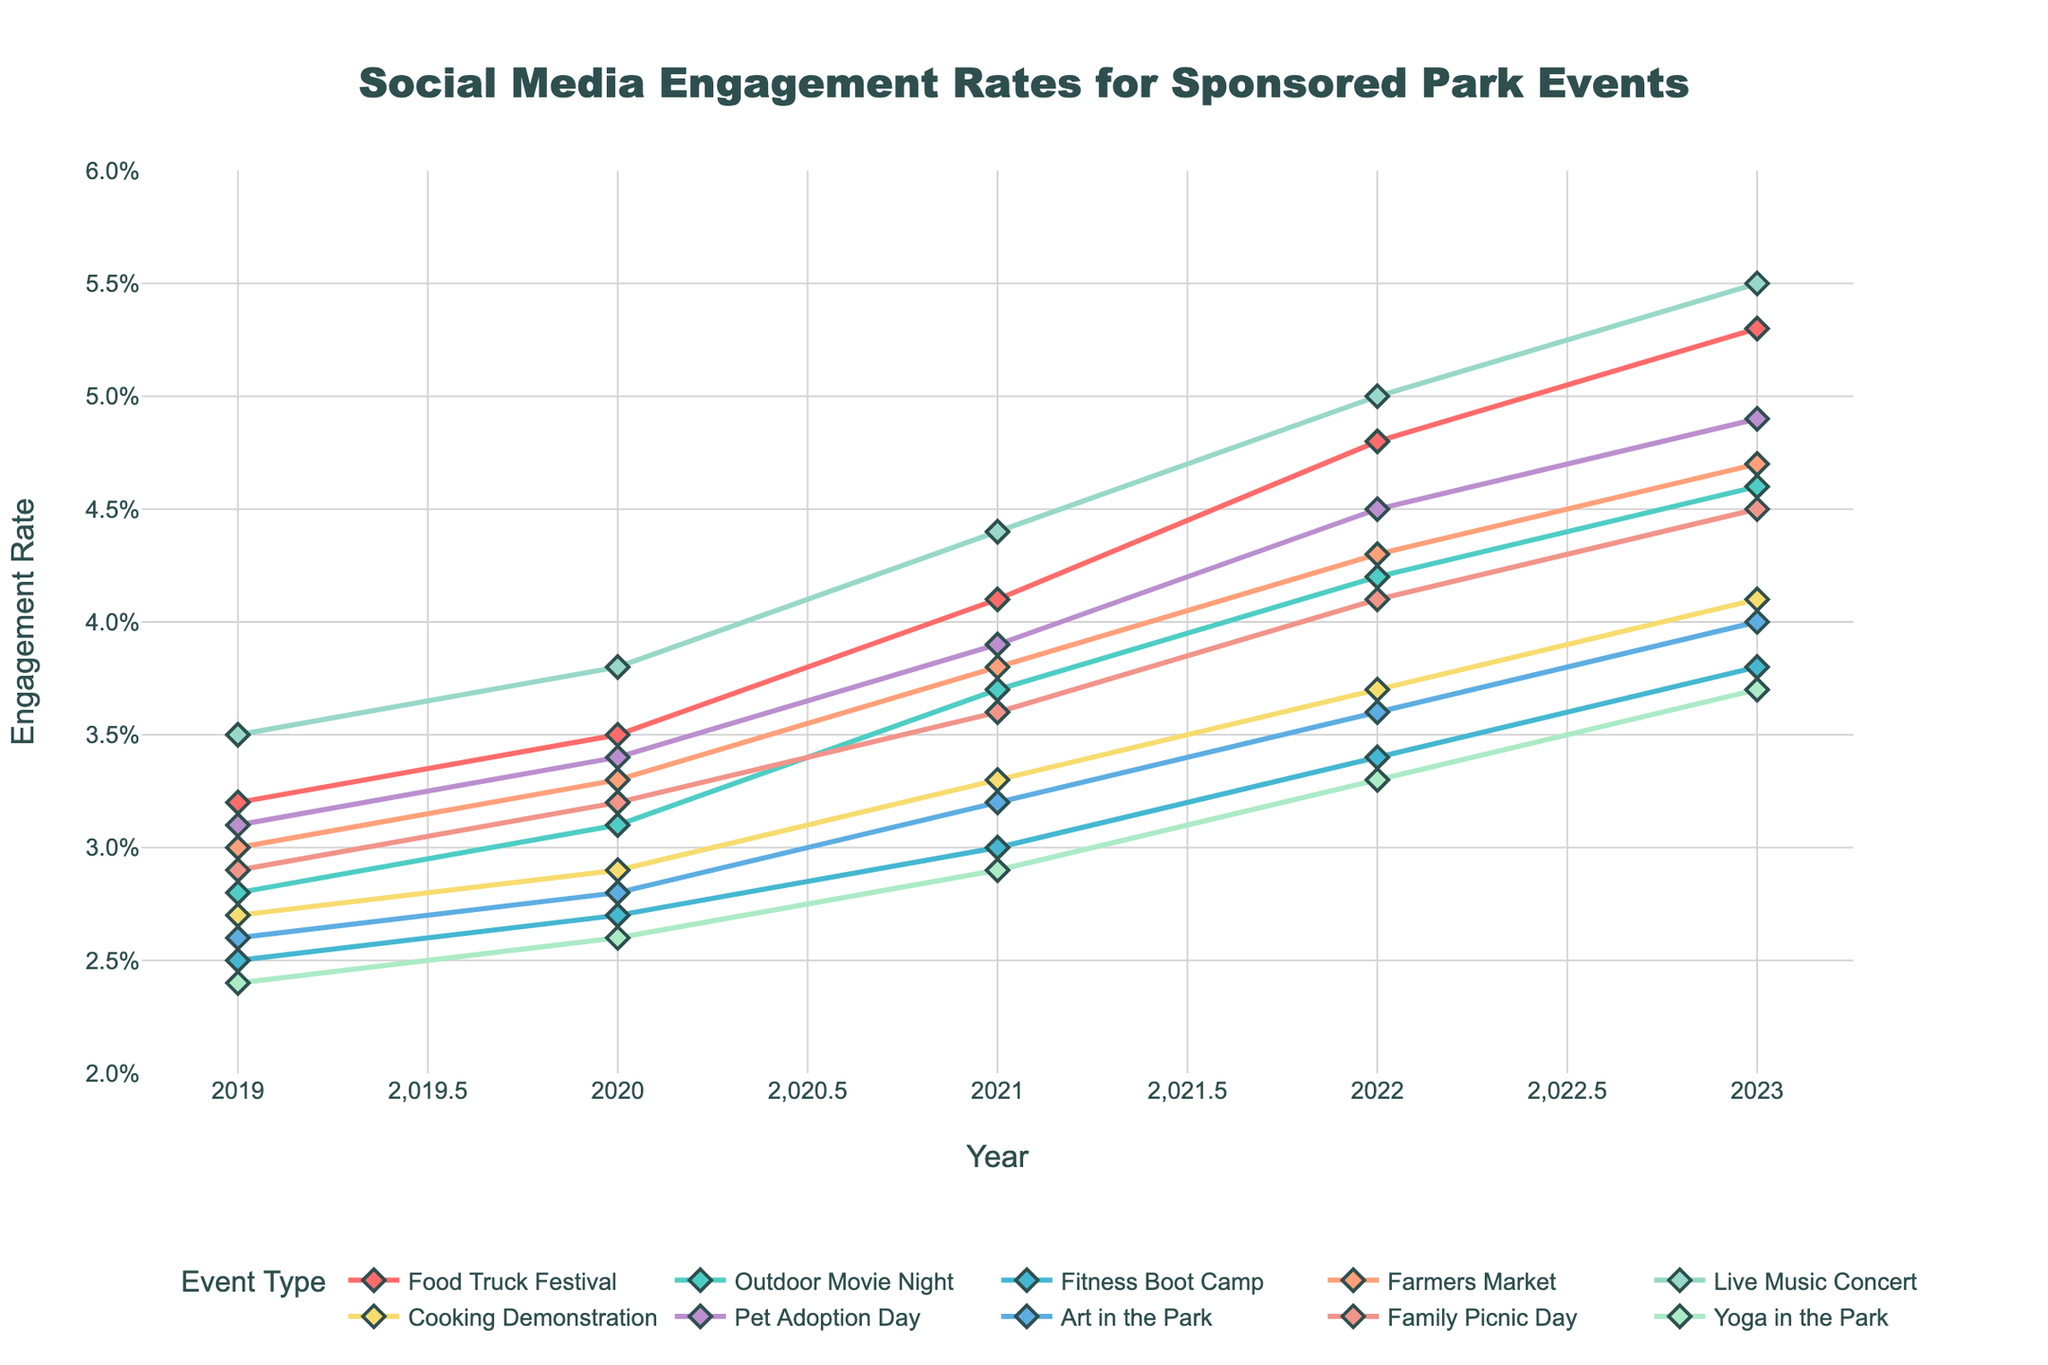What's the most popular event in terms of social media engagement in 2023? Look at the engagement rates for each event type in 2023. The event with the highest rate is the most popular. The highest engagement rate in 2023 is 5.5% for Live Music Concert.
Answer: Live Music Concert Which event showed the greatest increase in engagement rate from 2019 to 2023? Calculate the difference in engagement rates for each event from 2019 to 2023. The event with the highest difference is the one with the greatest increase. Live Music Concert increased from 3.5% to 5.5%, a difference of 2%.
Answer: Live Music Concert What's the general trend for Food Truck Festival engagement rates from 2019 to 2023? Observe the line representing Food Truck Festival. From 2019 to 2023, the line shows a steady upward trend, indicating increasing engagement rates over time.
Answer: Increasing How does the engagement rate of Farmers Market in 2023 compare to that of Outdoor Movie Night in 2023? Compare the engagement rates of Farmers Market and Outdoor Movie Night in 2023. Farmers Market has a rate of 4.7%, whereas Outdoor Movie Night has a rate of 4.6%.
Answer: Farmers Market is higher What is the average engagement rate for Fitness Boot Camp from 2019 to 2023? Add the engagement rates for Fitness Boot Camp from 2019 to 2023 and then divide by the number of years. (2.5% + 2.7% + 3.0% + 3.4% + 3.8%) / 5 = 3.08%
Answer: 3.08% Which event types had engagement rates of 4.0% or higher in 2021? Look for events that have engagement rates of 4.0% or higher in the year 2021. Live Music Concert (4.4%) and Pet Adoption Day (4.5%) meet this criterion.
Answer: Live Music Concert, Pet Adoption Day Which event type had the smallest engagement rate increase from 2021 to 2022? Calculate the difference in engagement rates for each event between 2021 and 2022. The event with the smallest increase is Yoga in the Park, from 2.9% to 3.3%, a difference of 0.4%.
Answer: Yoga in the Park What was the engagement rate trend for Cooking Demonstration over the five years? Examine the line representing Cooking Demonstration from 2019 to 2023. The engagement rate shows a consistent upward trend over these years.
Answer: Increasing Compare the engagement rate trends of Art in the Park and Family Picnic Day from 2019 to 2023. Follow the lines representing both events from 2019 to 2023. Both show an increasing trend, but Family Picnic Day has a higher overall increase. Art in the Park (2.6% to 4.0%); Family Picnic Day (2.9% to 4.5%).
Answer: Both increasing, Family Picnic Day higher What's the difference in engagement rates between Food Truck Festival and Fitness Boot Camp in 2023? Subtract the engagement rate of Fitness Boot Camp in 2023 from that of Food Truck Festival in 2023. 5.3% - 3.8% = 1.5%.
Answer: 1.5% 